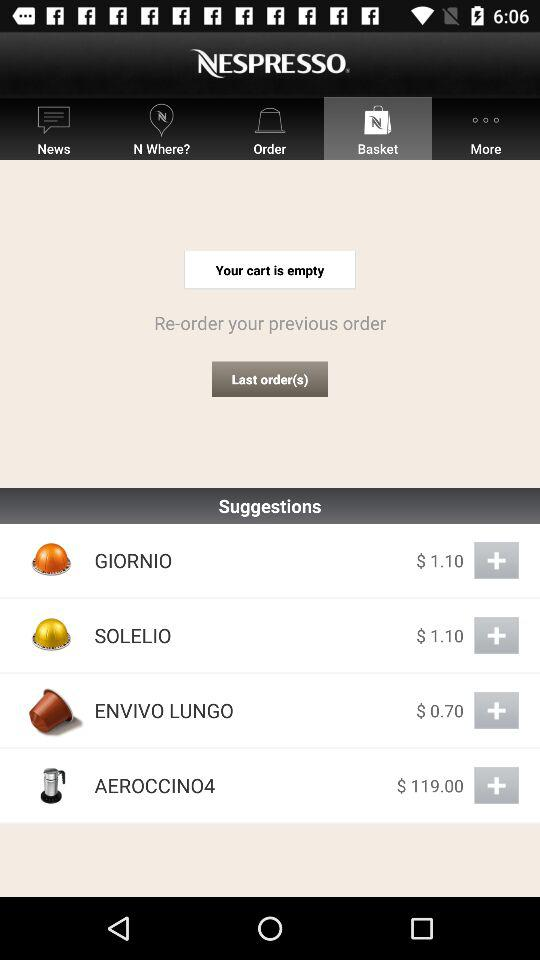What is the price of "GIORNIO"? The price of "GIORNIO" is $1.10. 